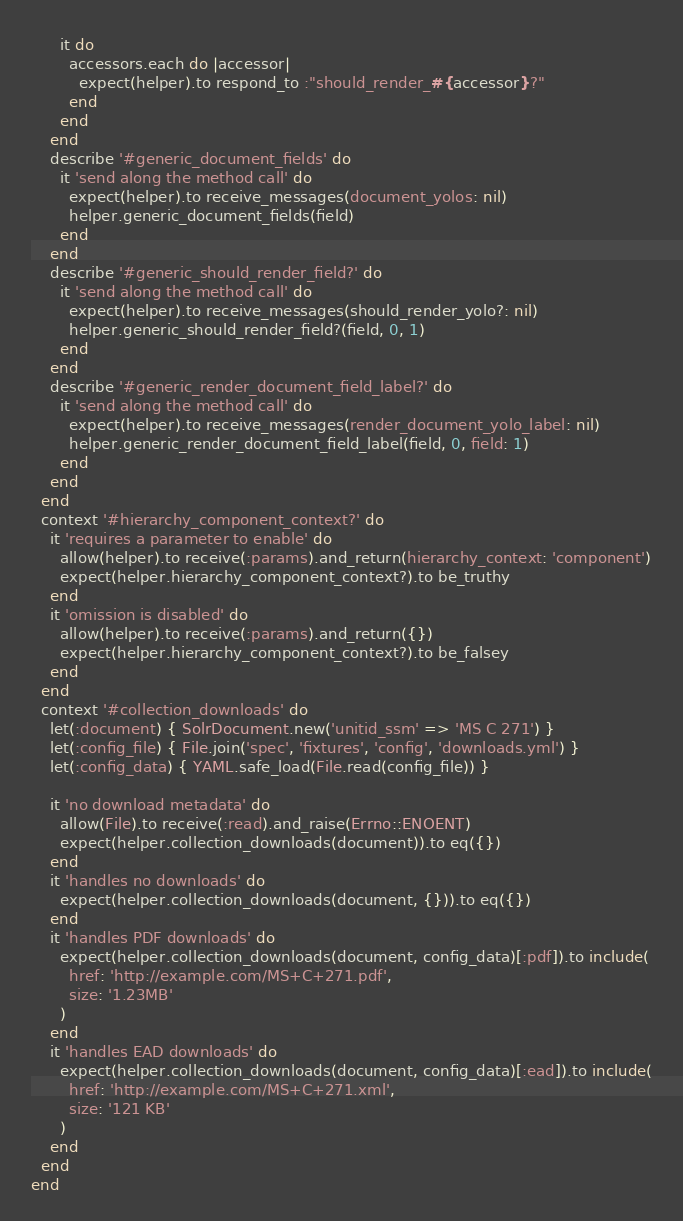<code> <loc_0><loc_0><loc_500><loc_500><_Ruby_>      it do
        accessors.each do |accessor|
          expect(helper).to respond_to :"should_render_#{accessor}?"
        end
      end
    end
    describe '#generic_document_fields' do
      it 'send along the method call' do
        expect(helper).to receive_messages(document_yolos: nil)
        helper.generic_document_fields(field)
      end
    end
    describe '#generic_should_render_field?' do
      it 'send along the method call' do
        expect(helper).to receive_messages(should_render_yolo?: nil)
        helper.generic_should_render_field?(field, 0, 1)
      end
    end
    describe '#generic_render_document_field_label?' do
      it 'send along the method call' do
        expect(helper).to receive_messages(render_document_yolo_label: nil)
        helper.generic_render_document_field_label(field, 0, field: 1)
      end
    end
  end
  context '#hierarchy_component_context?' do
    it 'requires a parameter to enable' do
      allow(helper).to receive(:params).and_return(hierarchy_context: 'component')
      expect(helper.hierarchy_component_context?).to be_truthy
    end
    it 'omission is disabled' do
      allow(helper).to receive(:params).and_return({})
      expect(helper.hierarchy_component_context?).to be_falsey
    end
  end
  context '#collection_downloads' do
    let(:document) { SolrDocument.new('unitid_ssm' => 'MS C 271') }
    let(:config_file) { File.join('spec', 'fixtures', 'config', 'downloads.yml') }
    let(:config_data) { YAML.safe_load(File.read(config_file)) }

    it 'no download metadata' do
      allow(File).to receive(:read).and_raise(Errno::ENOENT)
      expect(helper.collection_downloads(document)).to eq({})
    end
    it 'handles no downloads' do
      expect(helper.collection_downloads(document, {})).to eq({})
    end
    it 'handles PDF downloads' do
      expect(helper.collection_downloads(document, config_data)[:pdf]).to include(
        href: 'http://example.com/MS+C+271.pdf',
        size: '1.23MB'
      )
    end
    it 'handles EAD downloads' do
      expect(helper.collection_downloads(document, config_data)[:ead]).to include(
        href: 'http://example.com/MS+C+271.xml',
        size: '121 KB'
      )
    end
  end
end
</code> 